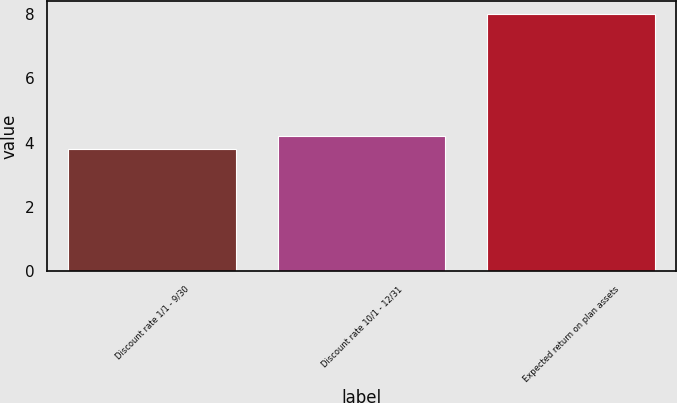Convert chart to OTSL. <chart><loc_0><loc_0><loc_500><loc_500><bar_chart><fcel>Discount rate 1/1 - 9/30<fcel>Discount rate 10/1 - 12/31<fcel>Expected return on plan assets<nl><fcel>3.8<fcel>4.22<fcel>8<nl></chart> 